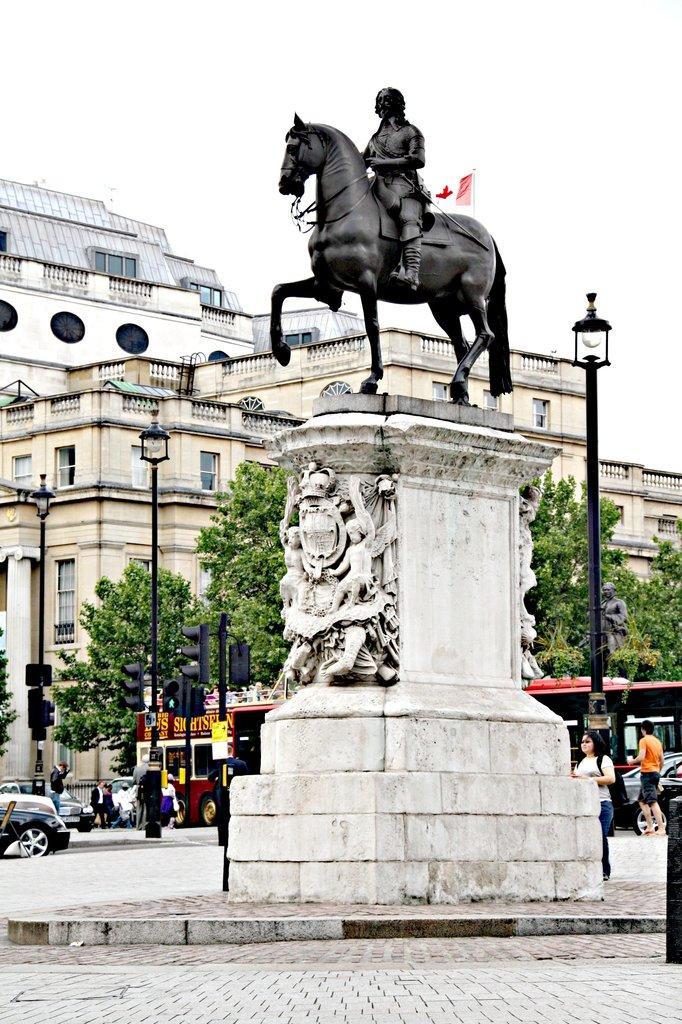Please provide a concise description of this image. In this picture there is a statue of a man who is riding a horse on the top of the image and there are some buildings around the area of the image and trees around the area of the image, it seems to be a road side view, there are cars and buses road signs in the image. 